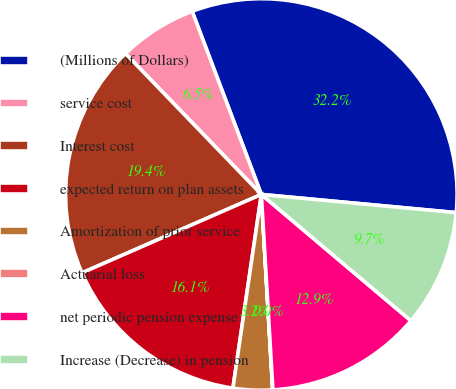Convert chart to OTSL. <chart><loc_0><loc_0><loc_500><loc_500><pie_chart><fcel>(Millions of Dollars)<fcel>service cost<fcel>Interest cost<fcel>expected return on plan assets<fcel>Amortization of prior service<fcel>Actuarial loss<fcel>net periodic pension expense<fcel>Increase (Decrease) in pension<nl><fcel>32.23%<fcel>6.46%<fcel>19.35%<fcel>16.12%<fcel>3.24%<fcel>0.02%<fcel>12.9%<fcel>9.68%<nl></chart> 